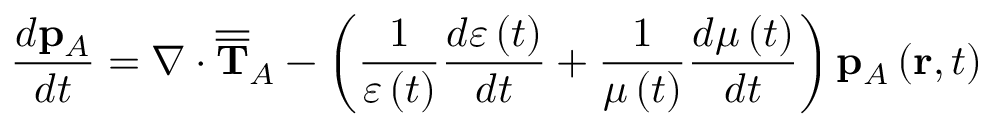<formula> <loc_0><loc_0><loc_500><loc_500>\frac { d p _ { A } } { d t } = \nabla \cdot \overline { { \overline { T } } } _ { A } - \left ( \frac { 1 } { \varepsilon \left ( t \right ) } \frac { d \varepsilon \left ( t \right ) } { d t } + \frac { 1 } { \mu \left ( t \right ) } \frac { d \mu \left ( t \right ) } { d t } \right ) p _ { A } \left ( r , t \right )</formula> 